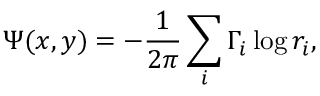<formula> <loc_0><loc_0><loc_500><loc_500>\Psi ( x , y ) = - \frac { 1 } { 2 \pi } \sum _ { i } \Gamma _ { i } \log r _ { i } ,</formula> 